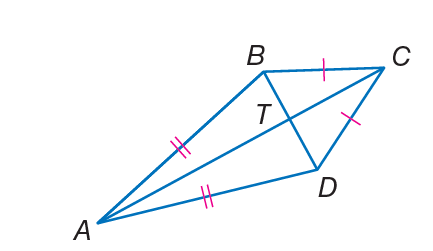Answer the mathemtical geometry problem and directly provide the correct option letter.
Question: If B T = 5 and T C = 8, find C D.
Choices: A: \sqrt { 89 } B: 25 C: 35 D: 64 A 